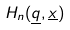<formula> <loc_0><loc_0><loc_500><loc_500>H _ { n } ( \underline { q } , \underline { x } )</formula> 